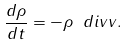Convert formula to latex. <formula><loc_0><loc_0><loc_500><loc_500>\frac { d \rho } { d t } = - \rho \ d i v { v } .</formula> 